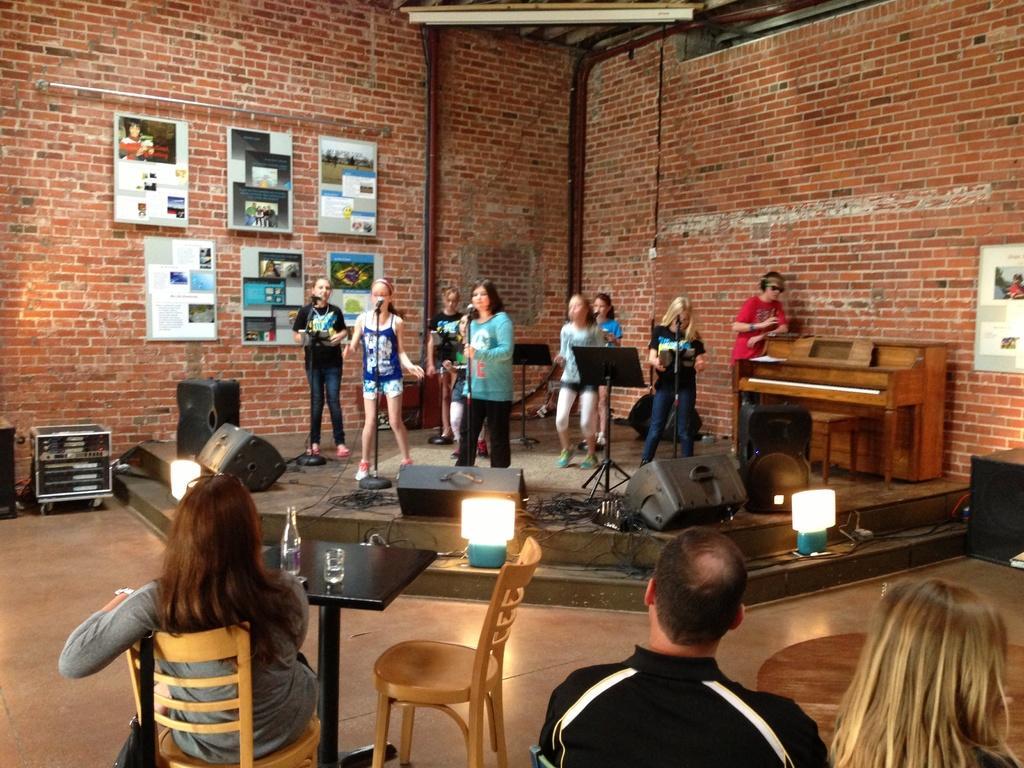Please provide a concise description of this image. On the background of the picture we can see a wall with bricks. these are the boards. This is a table. We can see few people sitting on the chiars here. This is a table. On the table we can see a bottle and a glass. These are electronic devices. On the platform we can see all women standing and singing. 